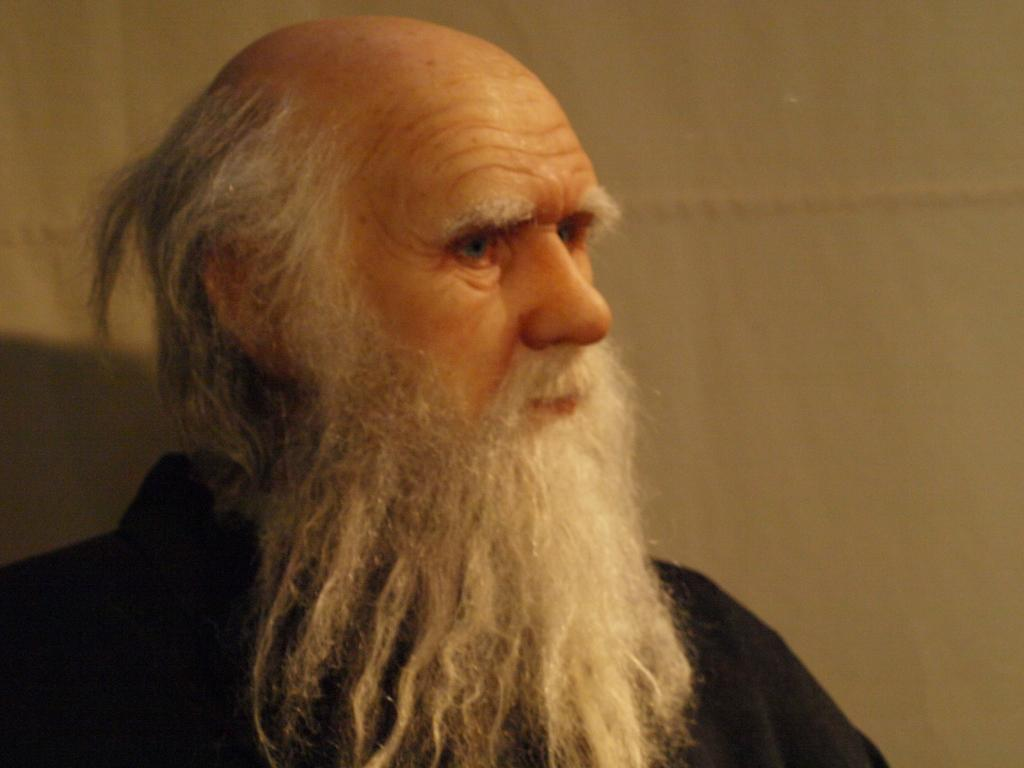Who is the main subject in the image? There is an old man in the image. What can be observed about the old man's appearance? The old man has a white beard. Where is the old man located in the image? The old man is in the center of the image. How many balloons are tied to the old man's beard in the image? There are no balloons present in the image, and therefore none are tied to the old man's beard. 